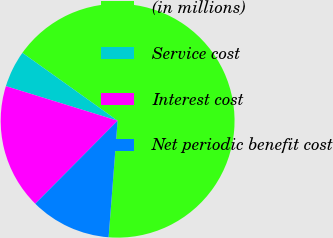Convert chart to OTSL. <chart><loc_0><loc_0><loc_500><loc_500><pie_chart><fcel>(in millions)<fcel>Service cost<fcel>Interest cost<fcel>Net periodic benefit cost<nl><fcel>66.37%<fcel>5.08%<fcel>17.34%<fcel>11.21%<nl></chart> 